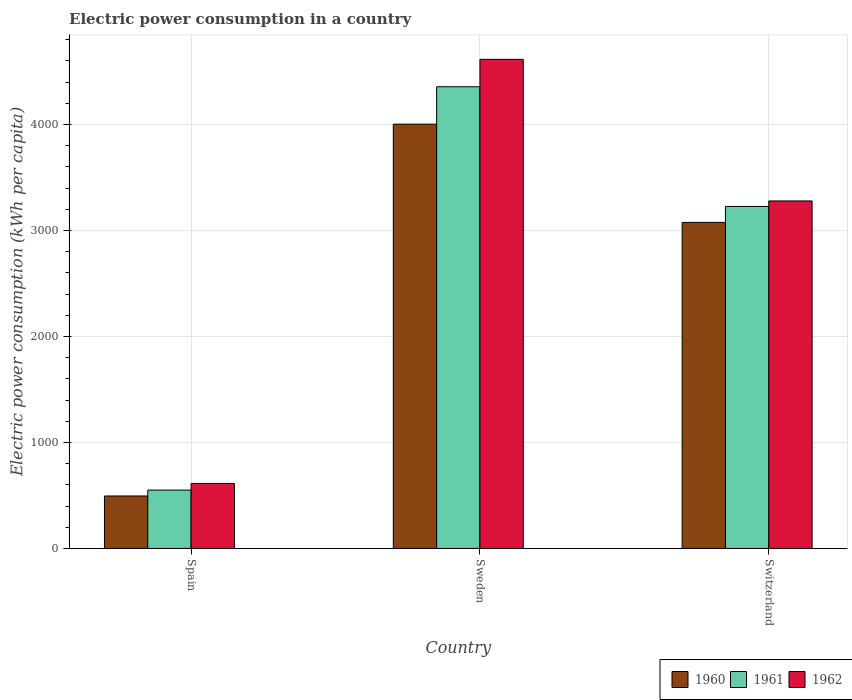How many groups of bars are there?
Provide a short and direct response. 3. Are the number of bars per tick equal to the number of legend labels?
Your answer should be compact. Yes. Are the number of bars on each tick of the X-axis equal?
Keep it short and to the point. Yes. How many bars are there on the 1st tick from the left?
Make the answer very short. 3. How many bars are there on the 1st tick from the right?
Ensure brevity in your answer.  3. What is the label of the 1st group of bars from the left?
Your answer should be very brief. Spain. In how many cases, is the number of bars for a given country not equal to the number of legend labels?
Make the answer very short. 0. What is the electric power consumption in in 1961 in Switzerland?
Your answer should be very brief. 3225.99. Across all countries, what is the maximum electric power consumption in in 1962?
Your answer should be compact. 4613.98. Across all countries, what is the minimum electric power consumption in in 1960?
Your answer should be compact. 494.8. What is the total electric power consumption in in 1962 in the graph?
Your answer should be compact. 8505.23. What is the difference between the electric power consumption in in 1960 in Sweden and that in Switzerland?
Offer a very short reply. 926.77. What is the difference between the electric power consumption in in 1960 in Switzerland and the electric power consumption in in 1961 in Spain?
Provide a succinct answer. 2525.11. What is the average electric power consumption in in 1961 per country?
Offer a terse response. 2710.63. What is the difference between the electric power consumption in of/in 1960 and electric power consumption in of/in 1961 in Switzerland?
Offer a very short reply. -150.44. What is the ratio of the electric power consumption in in 1961 in Spain to that in Sweden?
Your response must be concise. 0.13. What is the difference between the highest and the second highest electric power consumption in in 1961?
Give a very brief answer. -1129.46. What is the difference between the highest and the lowest electric power consumption in in 1960?
Keep it short and to the point. 3507.53. In how many countries, is the electric power consumption in in 1960 greater than the average electric power consumption in in 1960 taken over all countries?
Ensure brevity in your answer.  2. What does the 2nd bar from the left in Switzerland represents?
Offer a terse response. 1961. Is it the case that in every country, the sum of the electric power consumption in in 1962 and electric power consumption in in 1960 is greater than the electric power consumption in in 1961?
Your response must be concise. Yes. How many countries are there in the graph?
Make the answer very short. 3. Are the values on the major ticks of Y-axis written in scientific E-notation?
Provide a succinct answer. No. Does the graph contain grids?
Give a very brief answer. Yes. Where does the legend appear in the graph?
Ensure brevity in your answer.  Bottom right. How many legend labels are there?
Your answer should be very brief. 3. How are the legend labels stacked?
Make the answer very short. Horizontal. What is the title of the graph?
Provide a succinct answer. Electric power consumption in a country. What is the label or title of the Y-axis?
Your answer should be very brief. Electric power consumption (kWh per capita). What is the Electric power consumption (kWh per capita) of 1960 in Spain?
Your answer should be compact. 494.8. What is the Electric power consumption (kWh per capita) of 1961 in Spain?
Give a very brief answer. 550.44. What is the Electric power consumption (kWh per capita) in 1962 in Spain?
Make the answer very short. 613.25. What is the Electric power consumption (kWh per capita) in 1960 in Sweden?
Provide a short and direct response. 4002.32. What is the Electric power consumption (kWh per capita) in 1961 in Sweden?
Your answer should be very brief. 4355.45. What is the Electric power consumption (kWh per capita) of 1962 in Sweden?
Ensure brevity in your answer.  4613.98. What is the Electric power consumption (kWh per capita) in 1960 in Switzerland?
Keep it short and to the point. 3075.55. What is the Electric power consumption (kWh per capita) of 1961 in Switzerland?
Provide a short and direct response. 3225.99. What is the Electric power consumption (kWh per capita) of 1962 in Switzerland?
Your answer should be very brief. 3278.01. Across all countries, what is the maximum Electric power consumption (kWh per capita) in 1960?
Keep it short and to the point. 4002.32. Across all countries, what is the maximum Electric power consumption (kWh per capita) in 1961?
Offer a very short reply. 4355.45. Across all countries, what is the maximum Electric power consumption (kWh per capita) of 1962?
Provide a succinct answer. 4613.98. Across all countries, what is the minimum Electric power consumption (kWh per capita) in 1960?
Give a very brief answer. 494.8. Across all countries, what is the minimum Electric power consumption (kWh per capita) of 1961?
Provide a short and direct response. 550.44. Across all countries, what is the minimum Electric power consumption (kWh per capita) in 1962?
Ensure brevity in your answer.  613.25. What is the total Electric power consumption (kWh per capita) of 1960 in the graph?
Your response must be concise. 7572.67. What is the total Electric power consumption (kWh per capita) of 1961 in the graph?
Your answer should be very brief. 8131.88. What is the total Electric power consumption (kWh per capita) of 1962 in the graph?
Provide a short and direct response. 8505.23. What is the difference between the Electric power consumption (kWh per capita) of 1960 in Spain and that in Sweden?
Provide a succinct answer. -3507.53. What is the difference between the Electric power consumption (kWh per capita) in 1961 in Spain and that in Sweden?
Your answer should be very brief. -3805.02. What is the difference between the Electric power consumption (kWh per capita) of 1962 in Spain and that in Sweden?
Provide a short and direct response. -4000.73. What is the difference between the Electric power consumption (kWh per capita) of 1960 in Spain and that in Switzerland?
Offer a very short reply. -2580.75. What is the difference between the Electric power consumption (kWh per capita) of 1961 in Spain and that in Switzerland?
Give a very brief answer. -2675.56. What is the difference between the Electric power consumption (kWh per capita) in 1962 in Spain and that in Switzerland?
Offer a very short reply. -2664.76. What is the difference between the Electric power consumption (kWh per capita) in 1960 in Sweden and that in Switzerland?
Ensure brevity in your answer.  926.77. What is the difference between the Electric power consumption (kWh per capita) of 1961 in Sweden and that in Switzerland?
Offer a very short reply. 1129.46. What is the difference between the Electric power consumption (kWh per capita) of 1962 in Sweden and that in Switzerland?
Provide a short and direct response. 1335.97. What is the difference between the Electric power consumption (kWh per capita) in 1960 in Spain and the Electric power consumption (kWh per capita) in 1961 in Sweden?
Offer a very short reply. -3860.66. What is the difference between the Electric power consumption (kWh per capita) of 1960 in Spain and the Electric power consumption (kWh per capita) of 1962 in Sweden?
Provide a succinct answer. -4119.18. What is the difference between the Electric power consumption (kWh per capita) of 1961 in Spain and the Electric power consumption (kWh per capita) of 1962 in Sweden?
Ensure brevity in your answer.  -4063.54. What is the difference between the Electric power consumption (kWh per capita) in 1960 in Spain and the Electric power consumption (kWh per capita) in 1961 in Switzerland?
Provide a succinct answer. -2731.2. What is the difference between the Electric power consumption (kWh per capita) of 1960 in Spain and the Electric power consumption (kWh per capita) of 1962 in Switzerland?
Your answer should be compact. -2783.21. What is the difference between the Electric power consumption (kWh per capita) of 1961 in Spain and the Electric power consumption (kWh per capita) of 1962 in Switzerland?
Ensure brevity in your answer.  -2727.57. What is the difference between the Electric power consumption (kWh per capita) in 1960 in Sweden and the Electric power consumption (kWh per capita) in 1961 in Switzerland?
Keep it short and to the point. 776.33. What is the difference between the Electric power consumption (kWh per capita) in 1960 in Sweden and the Electric power consumption (kWh per capita) in 1962 in Switzerland?
Your answer should be compact. 724.32. What is the difference between the Electric power consumption (kWh per capita) of 1961 in Sweden and the Electric power consumption (kWh per capita) of 1962 in Switzerland?
Provide a short and direct response. 1077.45. What is the average Electric power consumption (kWh per capita) in 1960 per country?
Keep it short and to the point. 2524.22. What is the average Electric power consumption (kWh per capita) of 1961 per country?
Provide a short and direct response. 2710.63. What is the average Electric power consumption (kWh per capita) of 1962 per country?
Your answer should be compact. 2835.08. What is the difference between the Electric power consumption (kWh per capita) in 1960 and Electric power consumption (kWh per capita) in 1961 in Spain?
Provide a short and direct response. -55.64. What is the difference between the Electric power consumption (kWh per capita) in 1960 and Electric power consumption (kWh per capita) in 1962 in Spain?
Provide a short and direct response. -118.45. What is the difference between the Electric power consumption (kWh per capita) of 1961 and Electric power consumption (kWh per capita) of 1962 in Spain?
Your answer should be compact. -62.81. What is the difference between the Electric power consumption (kWh per capita) in 1960 and Electric power consumption (kWh per capita) in 1961 in Sweden?
Provide a succinct answer. -353.13. What is the difference between the Electric power consumption (kWh per capita) in 1960 and Electric power consumption (kWh per capita) in 1962 in Sweden?
Offer a terse response. -611.66. What is the difference between the Electric power consumption (kWh per capita) in 1961 and Electric power consumption (kWh per capita) in 1962 in Sweden?
Your response must be concise. -258.52. What is the difference between the Electric power consumption (kWh per capita) in 1960 and Electric power consumption (kWh per capita) in 1961 in Switzerland?
Keep it short and to the point. -150.44. What is the difference between the Electric power consumption (kWh per capita) in 1960 and Electric power consumption (kWh per capita) in 1962 in Switzerland?
Keep it short and to the point. -202.46. What is the difference between the Electric power consumption (kWh per capita) in 1961 and Electric power consumption (kWh per capita) in 1962 in Switzerland?
Your answer should be very brief. -52.01. What is the ratio of the Electric power consumption (kWh per capita) in 1960 in Spain to that in Sweden?
Provide a succinct answer. 0.12. What is the ratio of the Electric power consumption (kWh per capita) in 1961 in Spain to that in Sweden?
Keep it short and to the point. 0.13. What is the ratio of the Electric power consumption (kWh per capita) in 1962 in Spain to that in Sweden?
Your answer should be compact. 0.13. What is the ratio of the Electric power consumption (kWh per capita) of 1960 in Spain to that in Switzerland?
Your answer should be compact. 0.16. What is the ratio of the Electric power consumption (kWh per capita) of 1961 in Spain to that in Switzerland?
Provide a short and direct response. 0.17. What is the ratio of the Electric power consumption (kWh per capita) of 1962 in Spain to that in Switzerland?
Offer a terse response. 0.19. What is the ratio of the Electric power consumption (kWh per capita) of 1960 in Sweden to that in Switzerland?
Give a very brief answer. 1.3. What is the ratio of the Electric power consumption (kWh per capita) in 1961 in Sweden to that in Switzerland?
Make the answer very short. 1.35. What is the ratio of the Electric power consumption (kWh per capita) in 1962 in Sweden to that in Switzerland?
Give a very brief answer. 1.41. What is the difference between the highest and the second highest Electric power consumption (kWh per capita) in 1960?
Provide a short and direct response. 926.77. What is the difference between the highest and the second highest Electric power consumption (kWh per capita) of 1961?
Provide a short and direct response. 1129.46. What is the difference between the highest and the second highest Electric power consumption (kWh per capita) of 1962?
Your answer should be compact. 1335.97. What is the difference between the highest and the lowest Electric power consumption (kWh per capita) in 1960?
Offer a terse response. 3507.53. What is the difference between the highest and the lowest Electric power consumption (kWh per capita) of 1961?
Keep it short and to the point. 3805.02. What is the difference between the highest and the lowest Electric power consumption (kWh per capita) of 1962?
Make the answer very short. 4000.73. 